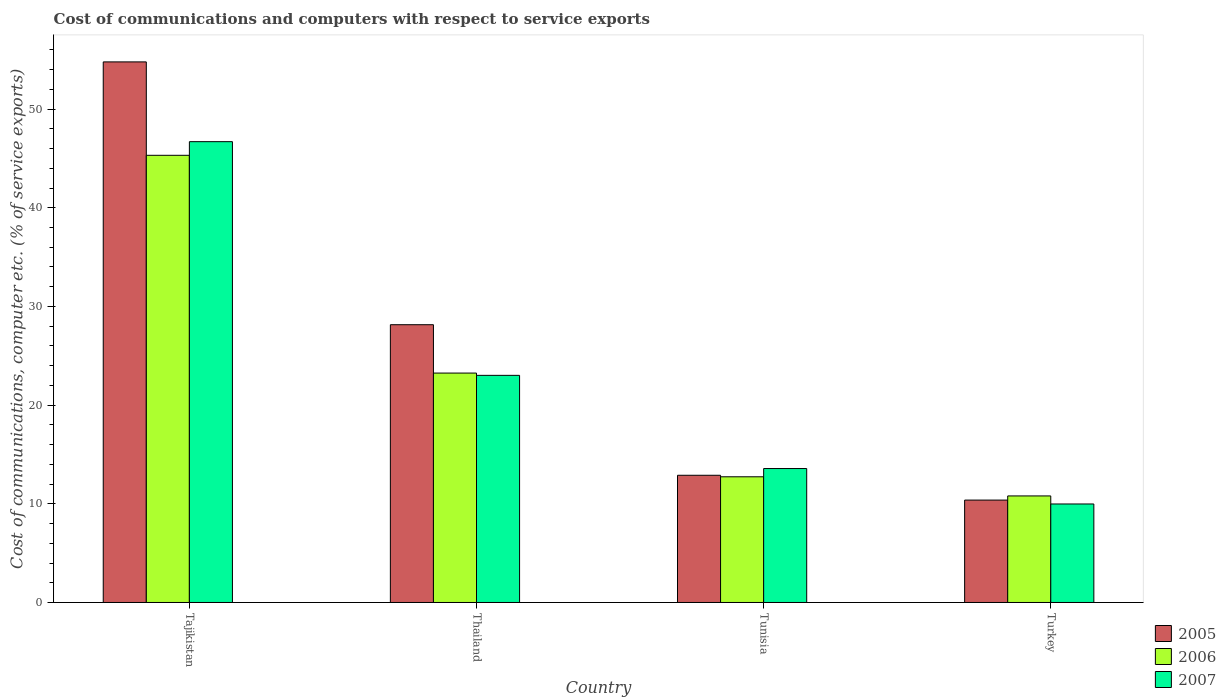How many groups of bars are there?
Provide a short and direct response. 4. Are the number of bars per tick equal to the number of legend labels?
Your answer should be very brief. Yes. How many bars are there on the 1st tick from the left?
Provide a succinct answer. 3. How many bars are there on the 4th tick from the right?
Make the answer very short. 3. In how many cases, is the number of bars for a given country not equal to the number of legend labels?
Provide a succinct answer. 0. What is the cost of communications and computers in 2005 in Thailand?
Provide a succinct answer. 28.15. Across all countries, what is the maximum cost of communications and computers in 2006?
Keep it short and to the point. 45.32. Across all countries, what is the minimum cost of communications and computers in 2006?
Provide a succinct answer. 10.8. In which country was the cost of communications and computers in 2005 maximum?
Make the answer very short. Tajikistan. In which country was the cost of communications and computers in 2007 minimum?
Make the answer very short. Turkey. What is the total cost of communications and computers in 2007 in the graph?
Provide a short and direct response. 93.27. What is the difference between the cost of communications and computers in 2005 in Tajikistan and that in Thailand?
Ensure brevity in your answer.  26.64. What is the difference between the cost of communications and computers in 2005 in Thailand and the cost of communications and computers in 2007 in Tunisia?
Make the answer very short. 14.58. What is the average cost of communications and computers in 2007 per country?
Make the answer very short. 23.32. What is the difference between the cost of communications and computers of/in 2006 and cost of communications and computers of/in 2007 in Thailand?
Your response must be concise. 0.23. In how many countries, is the cost of communications and computers in 2007 greater than 40 %?
Your answer should be compact. 1. What is the ratio of the cost of communications and computers in 2006 in Thailand to that in Turkey?
Provide a short and direct response. 2.15. Is the cost of communications and computers in 2006 in Tajikistan less than that in Thailand?
Offer a very short reply. No. What is the difference between the highest and the second highest cost of communications and computers in 2005?
Keep it short and to the point. 15.26. What is the difference between the highest and the lowest cost of communications and computers in 2006?
Keep it short and to the point. 34.52. What does the 3rd bar from the left in Tajikistan represents?
Offer a very short reply. 2007. Is it the case that in every country, the sum of the cost of communications and computers in 2006 and cost of communications and computers in 2007 is greater than the cost of communications and computers in 2005?
Make the answer very short. Yes. Are all the bars in the graph horizontal?
Ensure brevity in your answer.  No. Are the values on the major ticks of Y-axis written in scientific E-notation?
Your answer should be compact. No. Where does the legend appear in the graph?
Keep it short and to the point. Bottom right. What is the title of the graph?
Provide a succinct answer. Cost of communications and computers with respect to service exports. Does "2001" appear as one of the legend labels in the graph?
Your answer should be very brief. No. What is the label or title of the Y-axis?
Your answer should be compact. Cost of communications, computer etc. (% of service exports). What is the Cost of communications, computer etc. (% of service exports) in 2005 in Tajikistan?
Make the answer very short. 54.78. What is the Cost of communications, computer etc. (% of service exports) of 2006 in Tajikistan?
Keep it short and to the point. 45.32. What is the Cost of communications, computer etc. (% of service exports) of 2007 in Tajikistan?
Offer a very short reply. 46.7. What is the Cost of communications, computer etc. (% of service exports) in 2005 in Thailand?
Provide a short and direct response. 28.15. What is the Cost of communications, computer etc. (% of service exports) in 2006 in Thailand?
Make the answer very short. 23.25. What is the Cost of communications, computer etc. (% of service exports) in 2007 in Thailand?
Provide a short and direct response. 23.02. What is the Cost of communications, computer etc. (% of service exports) of 2005 in Tunisia?
Give a very brief answer. 12.89. What is the Cost of communications, computer etc. (% of service exports) of 2006 in Tunisia?
Ensure brevity in your answer.  12.74. What is the Cost of communications, computer etc. (% of service exports) in 2007 in Tunisia?
Make the answer very short. 13.57. What is the Cost of communications, computer etc. (% of service exports) in 2005 in Turkey?
Make the answer very short. 10.38. What is the Cost of communications, computer etc. (% of service exports) of 2006 in Turkey?
Offer a very short reply. 10.8. What is the Cost of communications, computer etc. (% of service exports) in 2007 in Turkey?
Provide a succinct answer. 9.98. Across all countries, what is the maximum Cost of communications, computer etc. (% of service exports) of 2005?
Make the answer very short. 54.78. Across all countries, what is the maximum Cost of communications, computer etc. (% of service exports) in 2006?
Your response must be concise. 45.32. Across all countries, what is the maximum Cost of communications, computer etc. (% of service exports) of 2007?
Ensure brevity in your answer.  46.7. Across all countries, what is the minimum Cost of communications, computer etc. (% of service exports) of 2005?
Keep it short and to the point. 10.38. Across all countries, what is the minimum Cost of communications, computer etc. (% of service exports) of 2006?
Ensure brevity in your answer.  10.8. Across all countries, what is the minimum Cost of communications, computer etc. (% of service exports) of 2007?
Keep it short and to the point. 9.98. What is the total Cost of communications, computer etc. (% of service exports) of 2005 in the graph?
Ensure brevity in your answer.  106.2. What is the total Cost of communications, computer etc. (% of service exports) in 2006 in the graph?
Make the answer very short. 92.1. What is the total Cost of communications, computer etc. (% of service exports) of 2007 in the graph?
Give a very brief answer. 93.27. What is the difference between the Cost of communications, computer etc. (% of service exports) in 2005 in Tajikistan and that in Thailand?
Provide a succinct answer. 26.64. What is the difference between the Cost of communications, computer etc. (% of service exports) of 2006 in Tajikistan and that in Thailand?
Your answer should be very brief. 22.07. What is the difference between the Cost of communications, computer etc. (% of service exports) of 2007 in Tajikistan and that in Thailand?
Your answer should be very brief. 23.68. What is the difference between the Cost of communications, computer etc. (% of service exports) of 2005 in Tajikistan and that in Tunisia?
Your answer should be compact. 41.89. What is the difference between the Cost of communications, computer etc. (% of service exports) of 2006 in Tajikistan and that in Tunisia?
Provide a short and direct response. 32.58. What is the difference between the Cost of communications, computer etc. (% of service exports) of 2007 in Tajikistan and that in Tunisia?
Provide a short and direct response. 33.13. What is the difference between the Cost of communications, computer etc. (% of service exports) in 2005 in Tajikistan and that in Turkey?
Keep it short and to the point. 44.41. What is the difference between the Cost of communications, computer etc. (% of service exports) of 2006 in Tajikistan and that in Turkey?
Give a very brief answer. 34.52. What is the difference between the Cost of communications, computer etc. (% of service exports) of 2007 in Tajikistan and that in Turkey?
Make the answer very short. 36.72. What is the difference between the Cost of communications, computer etc. (% of service exports) of 2005 in Thailand and that in Tunisia?
Provide a short and direct response. 15.26. What is the difference between the Cost of communications, computer etc. (% of service exports) in 2006 in Thailand and that in Tunisia?
Your answer should be very brief. 10.51. What is the difference between the Cost of communications, computer etc. (% of service exports) of 2007 in Thailand and that in Tunisia?
Your answer should be compact. 9.44. What is the difference between the Cost of communications, computer etc. (% of service exports) in 2005 in Thailand and that in Turkey?
Ensure brevity in your answer.  17.77. What is the difference between the Cost of communications, computer etc. (% of service exports) in 2006 in Thailand and that in Turkey?
Your answer should be very brief. 12.45. What is the difference between the Cost of communications, computer etc. (% of service exports) in 2007 in Thailand and that in Turkey?
Provide a succinct answer. 13.04. What is the difference between the Cost of communications, computer etc. (% of service exports) in 2005 in Tunisia and that in Turkey?
Give a very brief answer. 2.51. What is the difference between the Cost of communications, computer etc. (% of service exports) of 2006 in Tunisia and that in Turkey?
Provide a short and direct response. 1.94. What is the difference between the Cost of communications, computer etc. (% of service exports) of 2007 in Tunisia and that in Turkey?
Your response must be concise. 3.59. What is the difference between the Cost of communications, computer etc. (% of service exports) of 2005 in Tajikistan and the Cost of communications, computer etc. (% of service exports) of 2006 in Thailand?
Your answer should be compact. 31.53. What is the difference between the Cost of communications, computer etc. (% of service exports) in 2005 in Tajikistan and the Cost of communications, computer etc. (% of service exports) in 2007 in Thailand?
Make the answer very short. 31.77. What is the difference between the Cost of communications, computer etc. (% of service exports) of 2006 in Tajikistan and the Cost of communications, computer etc. (% of service exports) of 2007 in Thailand?
Give a very brief answer. 22.3. What is the difference between the Cost of communications, computer etc. (% of service exports) of 2005 in Tajikistan and the Cost of communications, computer etc. (% of service exports) of 2006 in Tunisia?
Your answer should be compact. 42.05. What is the difference between the Cost of communications, computer etc. (% of service exports) in 2005 in Tajikistan and the Cost of communications, computer etc. (% of service exports) in 2007 in Tunisia?
Keep it short and to the point. 41.21. What is the difference between the Cost of communications, computer etc. (% of service exports) in 2006 in Tajikistan and the Cost of communications, computer etc. (% of service exports) in 2007 in Tunisia?
Keep it short and to the point. 31.75. What is the difference between the Cost of communications, computer etc. (% of service exports) in 2005 in Tajikistan and the Cost of communications, computer etc. (% of service exports) in 2006 in Turkey?
Your answer should be very brief. 43.99. What is the difference between the Cost of communications, computer etc. (% of service exports) of 2005 in Tajikistan and the Cost of communications, computer etc. (% of service exports) of 2007 in Turkey?
Keep it short and to the point. 44.8. What is the difference between the Cost of communications, computer etc. (% of service exports) of 2006 in Tajikistan and the Cost of communications, computer etc. (% of service exports) of 2007 in Turkey?
Your response must be concise. 35.34. What is the difference between the Cost of communications, computer etc. (% of service exports) of 2005 in Thailand and the Cost of communications, computer etc. (% of service exports) of 2006 in Tunisia?
Ensure brevity in your answer.  15.41. What is the difference between the Cost of communications, computer etc. (% of service exports) in 2005 in Thailand and the Cost of communications, computer etc. (% of service exports) in 2007 in Tunisia?
Your answer should be very brief. 14.58. What is the difference between the Cost of communications, computer etc. (% of service exports) of 2006 in Thailand and the Cost of communications, computer etc. (% of service exports) of 2007 in Tunisia?
Provide a succinct answer. 9.68. What is the difference between the Cost of communications, computer etc. (% of service exports) in 2005 in Thailand and the Cost of communications, computer etc. (% of service exports) in 2006 in Turkey?
Your answer should be very brief. 17.35. What is the difference between the Cost of communications, computer etc. (% of service exports) of 2005 in Thailand and the Cost of communications, computer etc. (% of service exports) of 2007 in Turkey?
Offer a terse response. 18.17. What is the difference between the Cost of communications, computer etc. (% of service exports) in 2006 in Thailand and the Cost of communications, computer etc. (% of service exports) in 2007 in Turkey?
Your answer should be compact. 13.27. What is the difference between the Cost of communications, computer etc. (% of service exports) of 2005 in Tunisia and the Cost of communications, computer etc. (% of service exports) of 2006 in Turkey?
Ensure brevity in your answer.  2.09. What is the difference between the Cost of communications, computer etc. (% of service exports) of 2005 in Tunisia and the Cost of communications, computer etc. (% of service exports) of 2007 in Turkey?
Offer a very short reply. 2.91. What is the difference between the Cost of communications, computer etc. (% of service exports) of 2006 in Tunisia and the Cost of communications, computer etc. (% of service exports) of 2007 in Turkey?
Your response must be concise. 2.76. What is the average Cost of communications, computer etc. (% of service exports) in 2005 per country?
Make the answer very short. 26.55. What is the average Cost of communications, computer etc. (% of service exports) in 2006 per country?
Your answer should be compact. 23.03. What is the average Cost of communications, computer etc. (% of service exports) in 2007 per country?
Provide a succinct answer. 23.32. What is the difference between the Cost of communications, computer etc. (% of service exports) in 2005 and Cost of communications, computer etc. (% of service exports) in 2006 in Tajikistan?
Your response must be concise. 9.47. What is the difference between the Cost of communications, computer etc. (% of service exports) of 2005 and Cost of communications, computer etc. (% of service exports) of 2007 in Tajikistan?
Your response must be concise. 8.08. What is the difference between the Cost of communications, computer etc. (% of service exports) in 2006 and Cost of communications, computer etc. (% of service exports) in 2007 in Tajikistan?
Make the answer very short. -1.38. What is the difference between the Cost of communications, computer etc. (% of service exports) of 2005 and Cost of communications, computer etc. (% of service exports) of 2006 in Thailand?
Your answer should be compact. 4.9. What is the difference between the Cost of communications, computer etc. (% of service exports) in 2005 and Cost of communications, computer etc. (% of service exports) in 2007 in Thailand?
Ensure brevity in your answer.  5.13. What is the difference between the Cost of communications, computer etc. (% of service exports) of 2006 and Cost of communications, computer etc. (% of service exports) of 2007 in Thailand?
Your answer should be compact. 0.23. What is the difference between the Cost of communications, computer etc. (% of service exports) in 2005 and Cost of communications, computer etc. (% of service exports) in 2006 in Tunisia?
Your answer should be compact. 0.15. What is the difference between the Cost of communications, computer etc. (% of service exports) in 2005 and Cost of communications, computer etc. (% of service exports) in 2007 in Tunisia?
Provide a short and direct response. -0.68. What is the difference between the Cost of communications, computer etc. (% of service exports) of 2006 and Cost of communications, computer etc. (% of service exports) of 2007 in Tunisia?
Give a very brief answer. -0.84. What is the difference between the Cost of communications, computer etc. (% of service exports) in 2005 and Cost of communications, computer etc. (% of service exports) in 2006 in Turkey?
Keep it short and to the point. -0.42. What is the difference between the Cost of communications, computer etc. (% of service exports) in 2005 and Cost of communications, computer etc. (% of service exports) in 2007 in Turkey?
Offer a terse response. 0.39. What is the difference between the Cost of communications, computer etc. (% of service exports) in 2006 and Cost of communications, computer etc. (% of service exports) in 2007 in Turkey?
Offer a very short reply. 0.82. What is the ratio of the Cost of communications, computer etc. (% of service exports) in 2005 in Tajikistan to that in Thailand?
Make the answer very short. 1.95. What is the ratio of the Cost of communications, computer etc. (% of service exports) in 2006 in Tajikistan to that in Thailand?
Offer a very short reply. 1.95. What is the ratio of the Cost of communications, computer etc. (% of service exports) in 2007 in Tajikistan to that in Thailand?
Keep it short and to the point. 2.03. What is the ratio of the Cost of communications, computer etc. (% of service exports) of 2005 in Tajikistan to that in Tunisia?
Offer a very short reply. 4.25. What is the ratio of the Cost of communications, computer etc. (% of service exports) of 2006 in Tajikistan to that in Tunisia?
Provide a succinct answer. 3.56. What is the ratio of the Cost of communications, computer etc. (% of service exports) of 2007 in Tajikistan to that in Tunisia?
Your answer should be compact. 3.44. What is the ratio of the Cost of communications, computer etc. (% of service exports) in 2005 in Tajikistan to that in Turkey?
Your answer should be very brief. 5.28. What is the ratio of the Cost of communications, computer etc. (% of service exports) in 2006 in Tajikistan to that in Turkey?
Your answer should be very brief. 4.2. What is the ratio of the Cost of communications, computer etc. (% of service exports) in 2007 in Tajikistan to that in Turkey?
Your response must be concise. 4.68. What is the ratio of the Cost of communications, computer etc. (% of service exports) in 2005 in Thailand to that in Tunisia?
Keep it short and to the point. 2.18. What is the ratio of the Cost of communications, computer etc. (% of service exports) in 2006 in Thailand to that in Tunisia?
Give a very brief answer. 1.83. What is the ratio of the Cost of communications, computer etc. (% of service exports) of 2007 in Thailand to that in Tunisia?
Offer a terse response. 1.7. What is the ratio of the Cost of communications, computer etc. (% of service exports) of 2005 in Thailand to that in Turkey?
Provide a short and direct response. 2.71. What is the ratio of the Cost of communications, computer etc. (% of service exports) in 2006 in Thailand to that in Turkey?
Make the answer very short. 2.15. What is the ratio of the Cost of communications, computer etc. (% of service exports) in 2007 in Thailand to that in Turkey?
Provide a succinct answer. 2.31. What is the ratio of the Cost of communications, computer etc. (% of service exports) in 2005 in Tunisia to that in Turkey?
Give a very brief answer. 1.24. What is the ratio of the Cost of communications, computer etc. (% of service exports) of 2006 in Tunisia to that in Turkey?
Make the answer very short. 1.18. What is the ratio of the Cost of communications, computer etc. (% of service exports) of 2007 in Tunisia to that in Turkey?
Keep it short and to the point. 1.36. What is the difference between the highest and the second highest Cost of communications, computer etc. (% of service exports) in 2005?
Provide a succinct answer. 26.64. What is the difference between the highest and the second highest Cost of communications, computer etc. (% of service exports) in 2006?
Keep it short and to the point. 22.07. What is the difference between the highest and the second highest Cost of communications, computer etc. (% of service exports) of 2007?
Keep it short and to the point. 23.68. What is the difference between the highest and the lowest Cost of communications, computer etc. (% of service exports) of 2005?
Offer a very short reply. 44.41. What is the difference between the highest and the lowest Cost of communications, computer etc. (% of service exports) in 2006?
Provide a short and direct response. 34.52. What is the difference between the highest and the lowest Cost of communications, computer etc. (% of service exports) of 2007?
Provide a short and direct response. 36.72. 